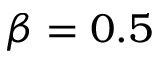Convert formula to latex. <formula><loc_0><loc_0><loc_500><loc_500>\beta = 0 . 5</formula> 